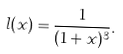<formula> <loc_0><loc_0><loc_500><loc_500>l ( x ) = \frac { 1 } { ( 1 + x ) ^ { 3 } } .</formula> 